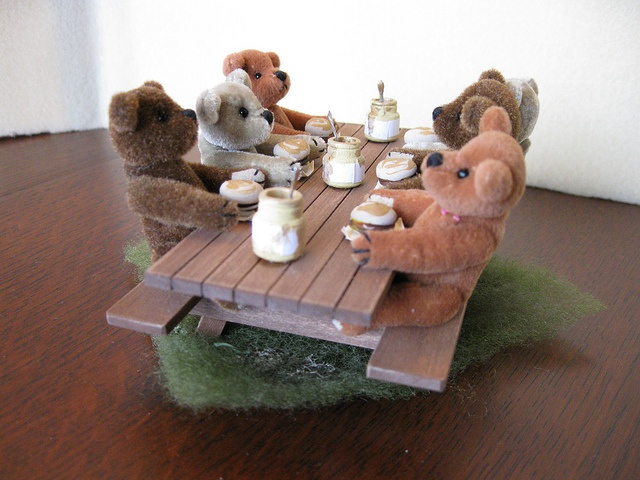Describe the objects in this image and their specific colors. I can see dining table in darkgray, gray, lightgray, and tan tones, teddy bear in darkgray, brown, and salmon tones, teddy bear in darkgray, gray, maroon, and black tones, teddy bear in darkgray, gray, and lightgray tones, and teddy bear in darkgray, gray, lightgray, and maroon tones in this image. 